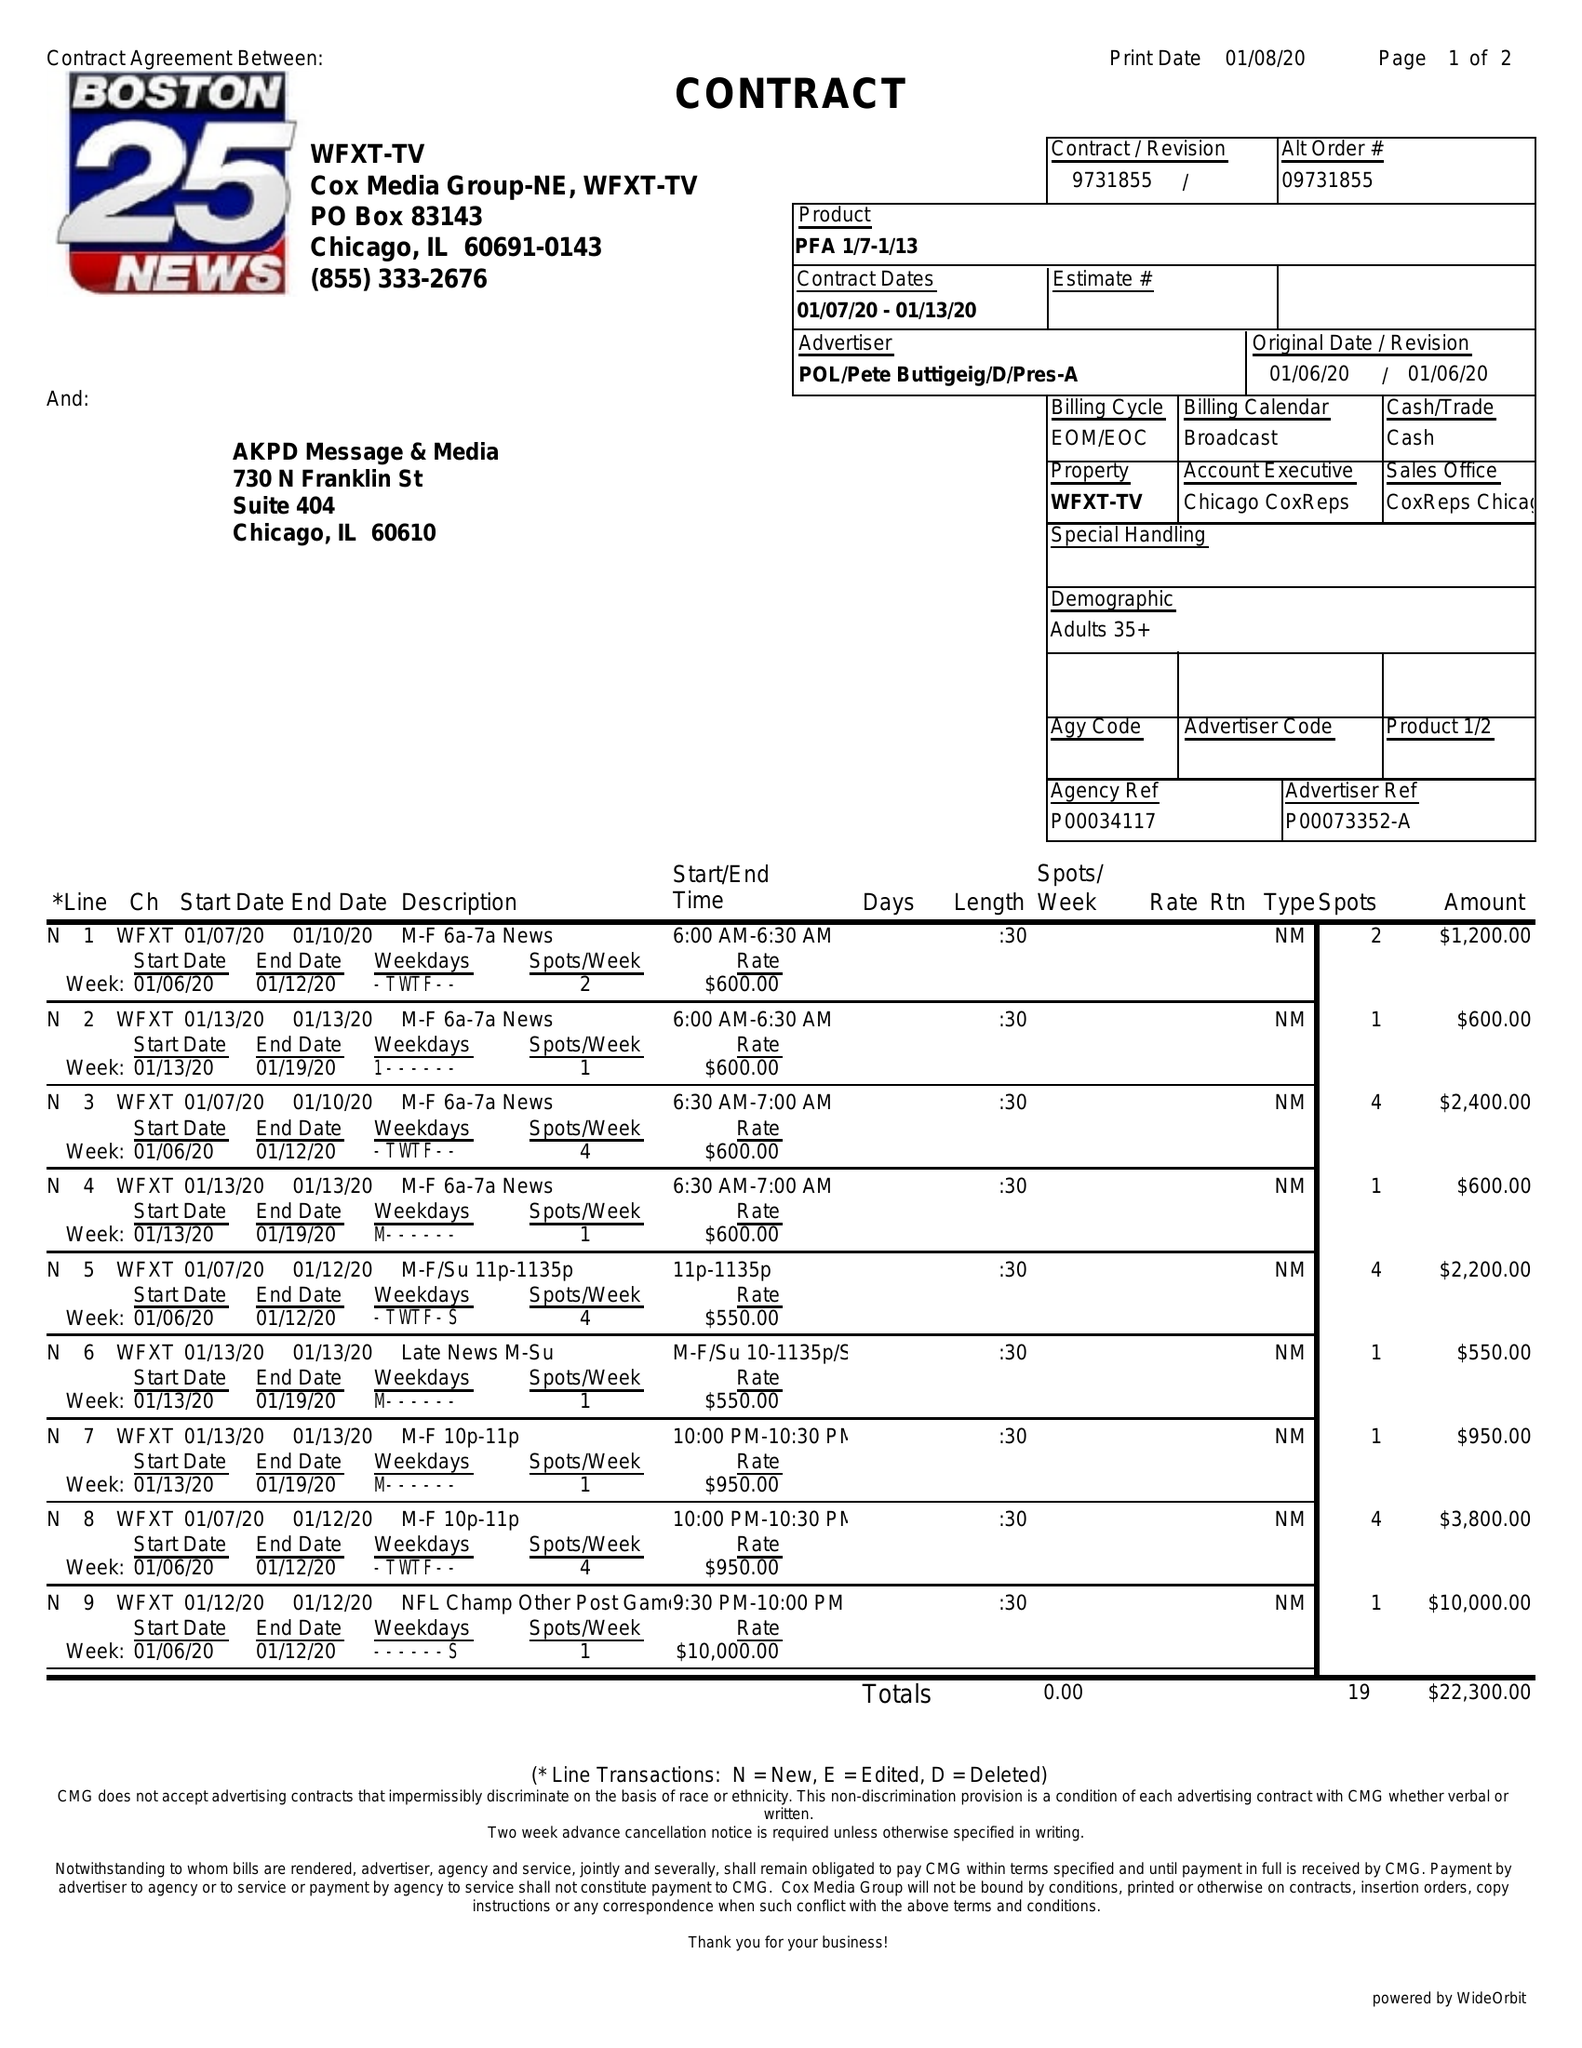What is the value for the advertiser?
Answer the question using a single word or phrase. POL/PETEBUTTIGEIG/D/PRES-A 